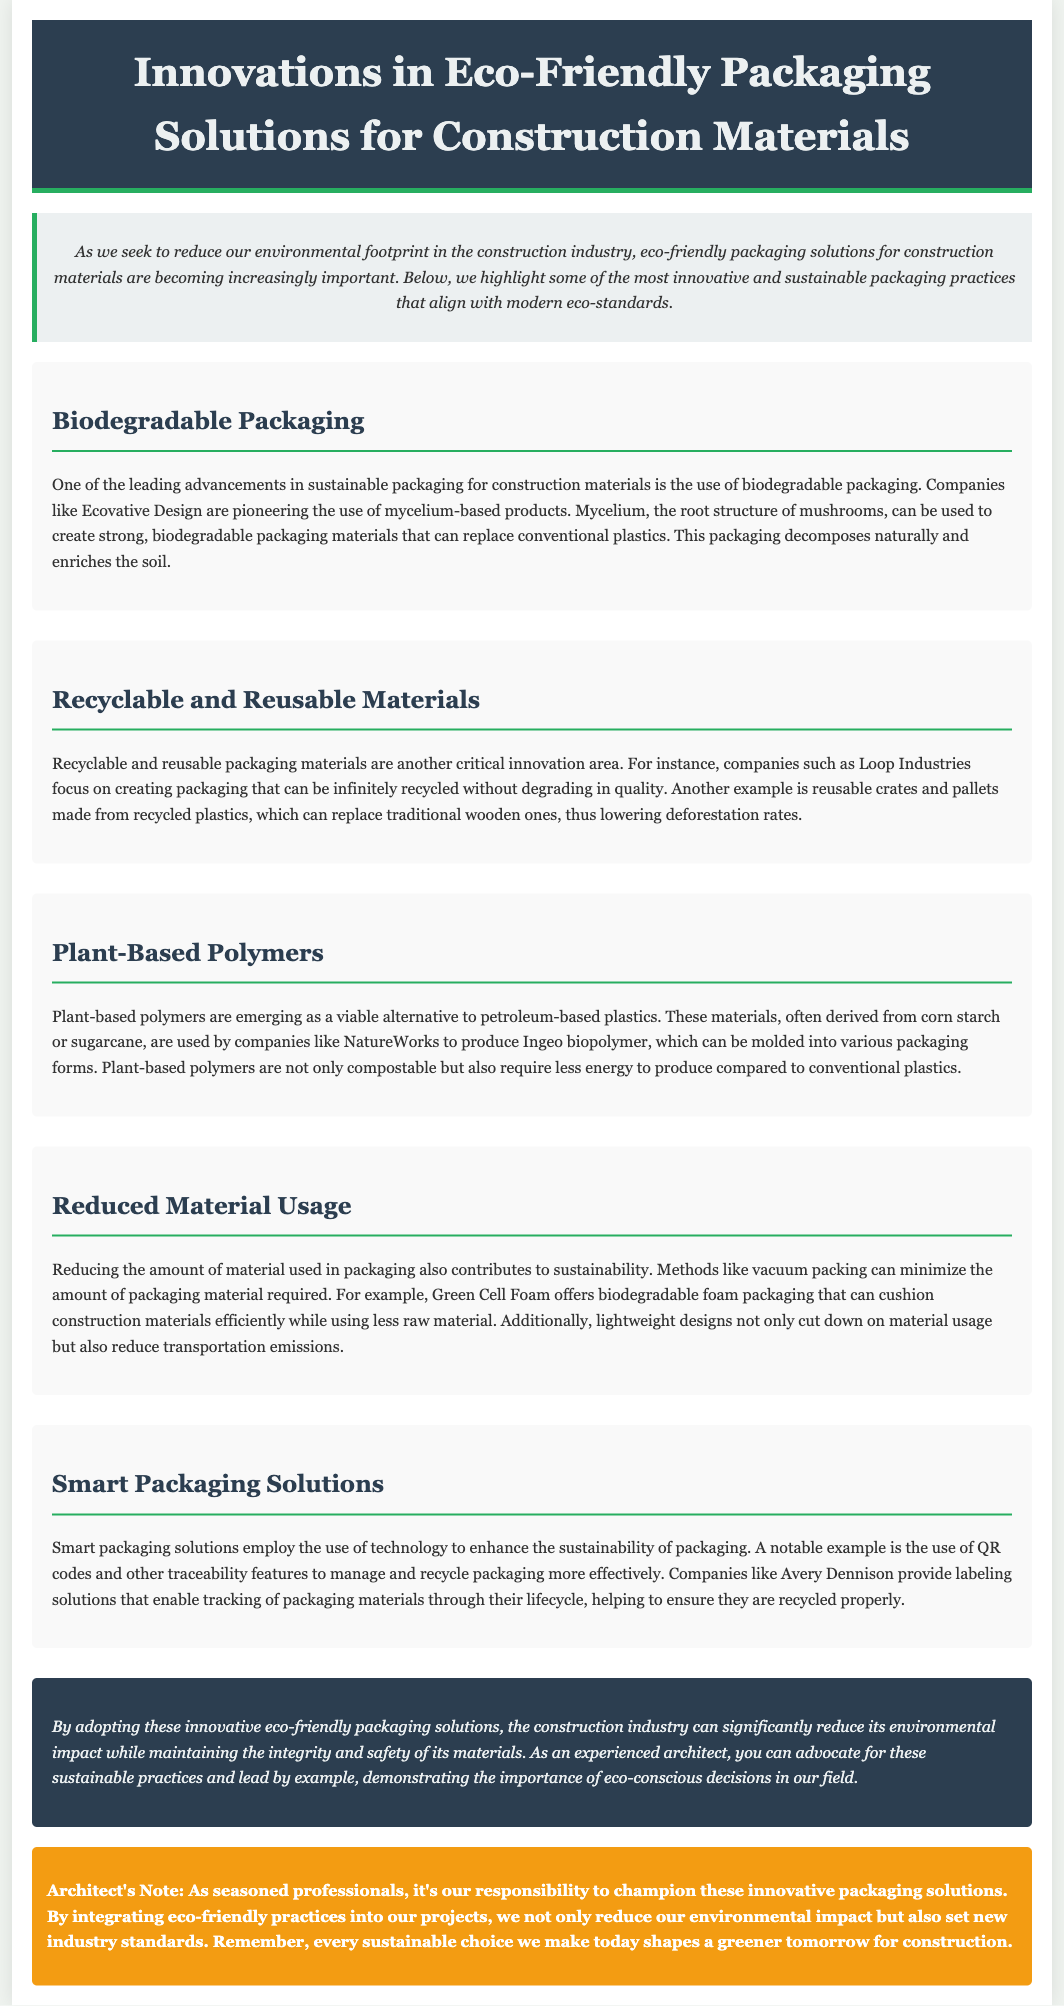What is the title of the document? The title is stated in the header section of the document.
Answer: Innovations in Eco-Friendly Packaging Solutions for Construction Materials Who is an example company using biodegradable packaging? The document mentions a specific company associated with biodegradable packaging technology.
Answer: Ecovative Design What is one benefit of plant-based polymers? The document outlines a key advantage of using plant-based polymers.
Answer: Compostable What technology is used in smart packaging solutions? The document describes the technology incorporated in smart packaging solutions to enhance sustainability.
Answer: QR codes What is one method to reduce material usage in packaging? The document provides an example of a method for minimizing packaging material.
Answer: Vacuum packing Which company focuses on recyclable and reusable materials? The document lists a specific company that creates recyclable and reusable materials.
Answer: Loop Industries What type of packaging does Green Cell Foam provide? The document identifies the type of packaging offered by Green Cell Foam.
Answer: Biodegradable foam How do smart packaging solutions help with recycling? The document explains the function of technology in smart packaging solutions regarding recycling.
Answer: Traceability features 